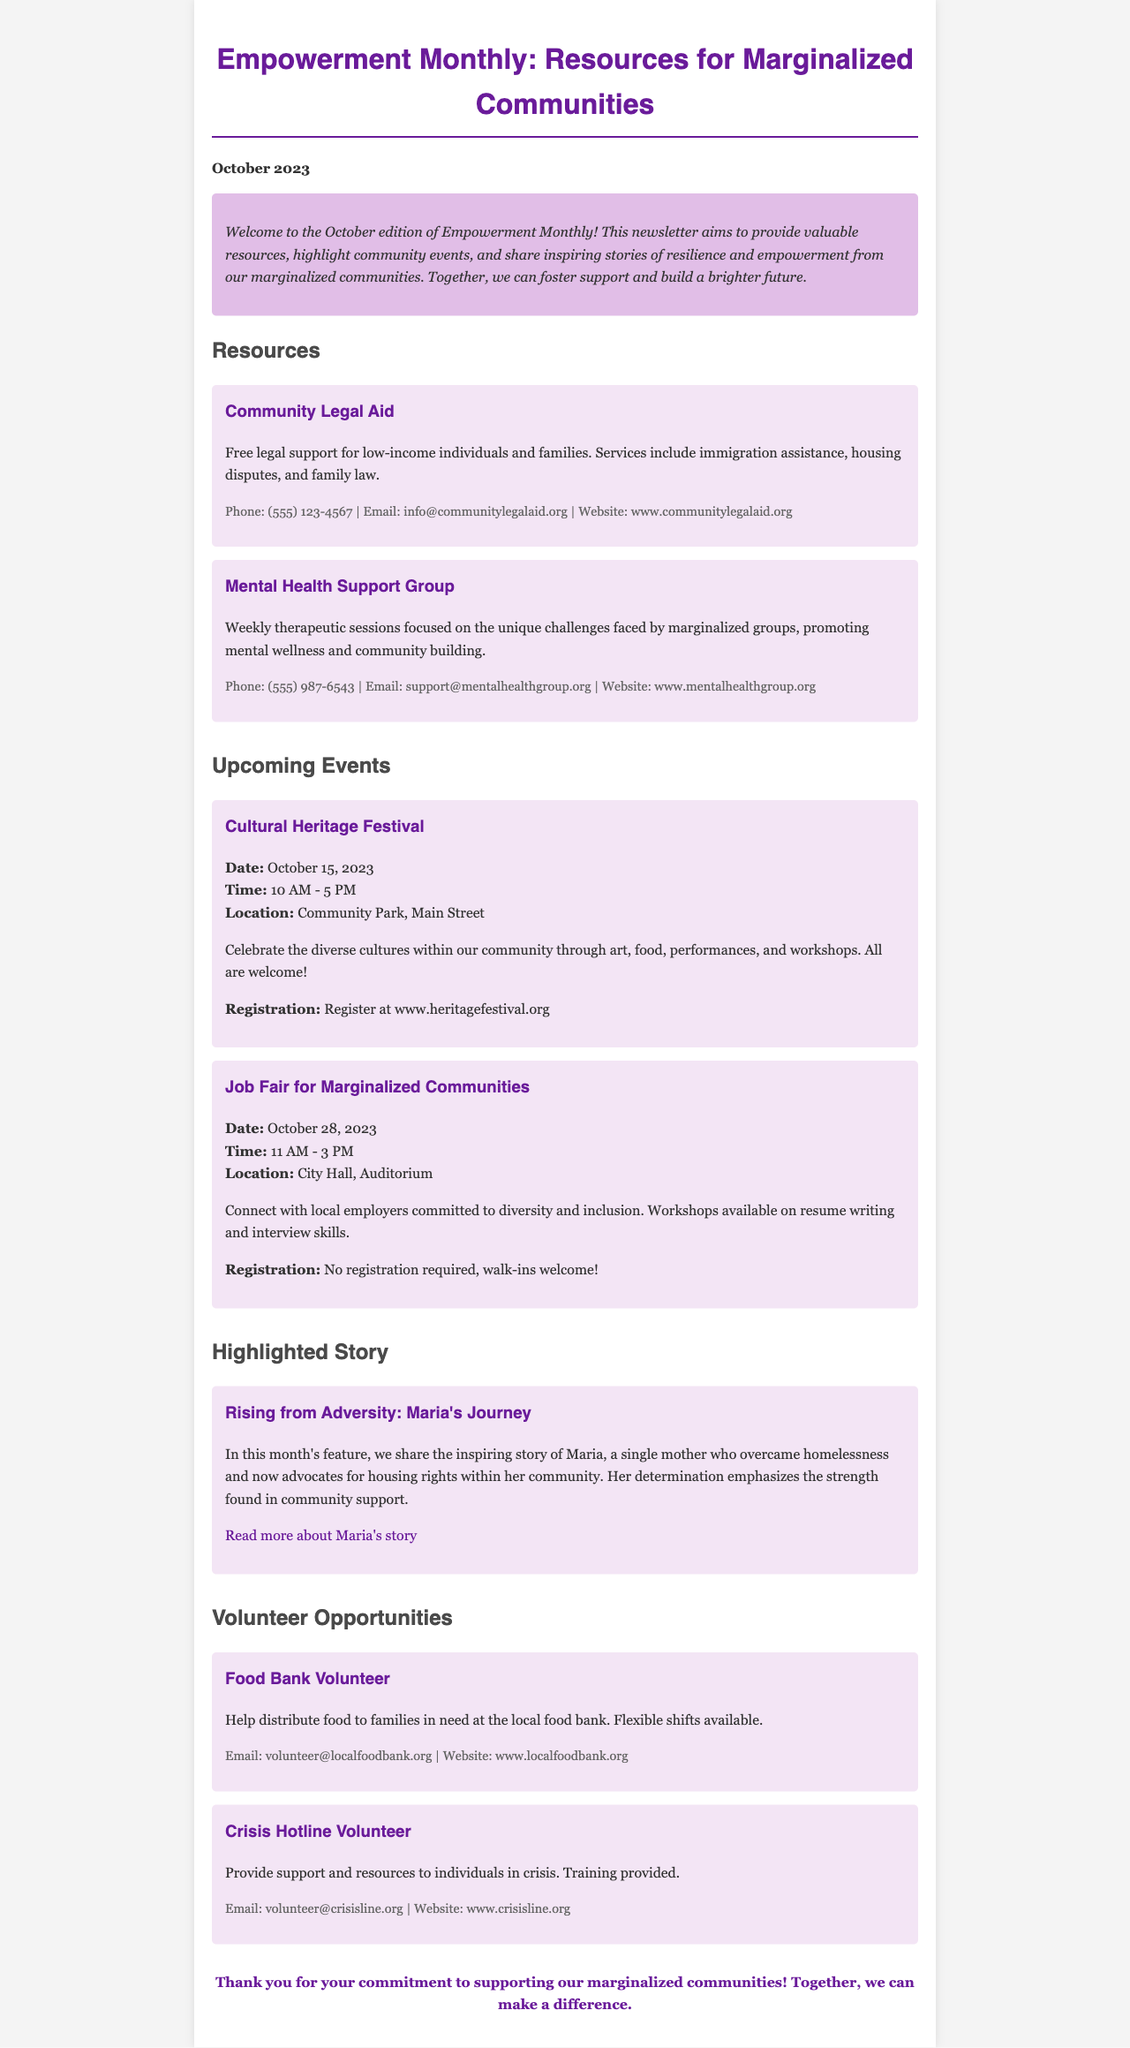What is the title of the newsletter? The title is prominently displayed at the top of the document.
Answer: Empowerment Monthly: Resources for Marginalized Communities What is the date of the newsletter? The date appears right below the title, indicating the month it pertains to.
Answer: October 2023 What resource offers immigration assistance? The resource section lists several services, including immigration support.
Answer: Community Legal Aid What event is scheduled for October 15, 2023? The events section provides details about a specific upcoming event.
Answer: Cultural Heritage Festival Who is the highlighted story about? The highlighted story section includes the name of the individual featured.
Answer: Maria What type of volunteer opportunity involves a hotline? The volunteer section specifies the nature of each opportunity.
Answer: Crisis Hotline Volunteer How can one register for the Job Fair? The document states the registration requirements for the job fair.
Answer: No registration required, walk-ins welcome! What is the main purpose of the newsletter? The introductory paragraph summarizes the overall goal of the newsletter.
Answer: Provide valuable resources What organization offers mental health support? The resources section includes contact information for various support services.
Answer: Mental Health Support Group 